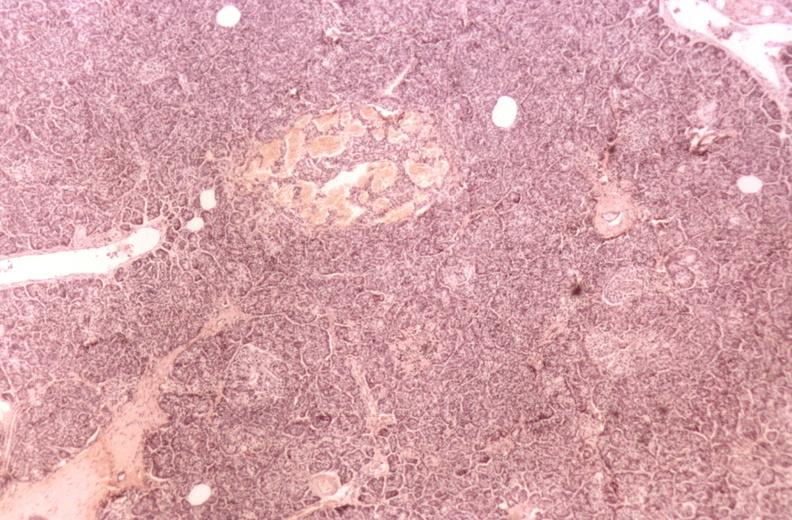does liver lesion show kidney, glomerular amyloid, diabetes mellitus?
Answer the question using a single word or phrase. No 